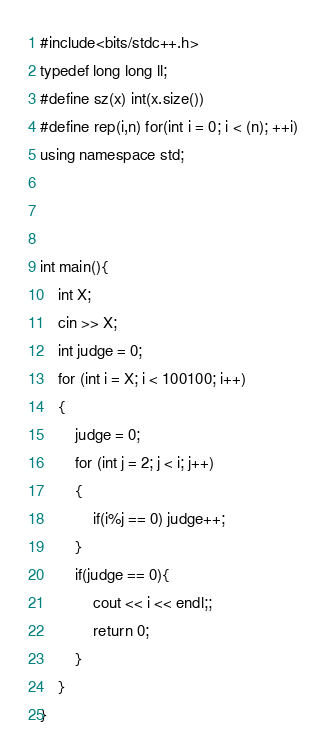<code> <loc_0><loc_0><loc_500><loc_500><_C++_>#include<bits/stdc++.h>
typedef long long ll;
#define sz(x) int(x.size())
#define rep(i,n) for(int i = 0; i < (n); ++i)
using namespace std;



int main(){
    int X;
    cin >> X;
    int judge = 0;
    for (int i = X; i < 100100; i++)
    {
        judge = 0;
        for (int j = 2; j < i; j++)
        {
            if(i%j == 0) judge++;
        }
        if(judge == 0){
            cout << i << endl;;
            return 0;
        }
    }
}</code> 